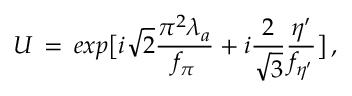Convert formula to latex. <formula><loc_0><loc_0><loc_500><loc_500>U \, = \, e x p \left [ i \sqrt { 2 } { \frac { \pi ^ { 2 } \lambda _ { a } } { f _ { \pi } } } + i { \frac { 2 } { \sqrt { 3 } } } { \frac { \eta ^ { \prime } } { f _ { \eta ^ { \prime } } } } \right ] \, ,</formula> 